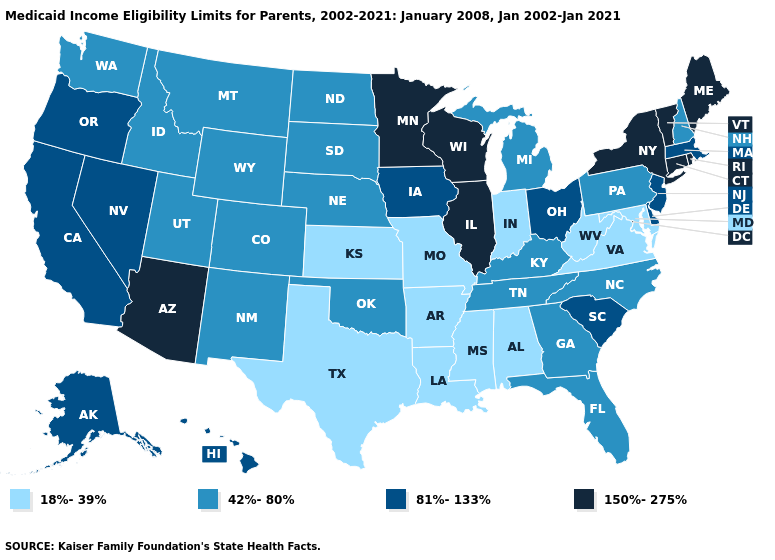Does the first symbol in the legend represent the smallest category?
Keep it brief. Yes. Among the states that border Minnesota , does Wisconsin have the highest value?
Write a very short answer. Yes. Name the states that have a value in the range 150%-275%?
Quick response, please. Arizona, Connecticut, Illinois, Maine, Minnesota, New York, Rhode Island, Vermont, Wisconsin. Is the legend a continuous bar?
Concise answer only. No. Name the states that have a value in the range 18%-39%?
Be succinct. Alabama, Arkansas, Indiana, Kansas, Louisiana, Maryland, Mississippi, Missouri, Texas, Virginia, West Virginia. What is the lowest value in the Northeast?
Keep it brief. 42%-80%. Name the states that have a value in the range 150%-275%?
Answer briefly. Arizona, Connecticut, Illinois, Maine, Minnesota, New York, Rhode Island, Vermont, Wisconsin. Name the states that have a value in the range 81%-133%?
Give a very brief answer. Alaska, California, Delaware, Hawaii, Iowa, Massachusetts, Nevada, New Jersey, Ohio, Oregon, South Carolina. What is the lowest value in the Northeast?
Answer briefly. 42%-80%. Which states hav the highest value in the Northeast?
Quick response, please. Connecticut, Maine, New York, Rhode Island, Vermont. Does Hawaii have the lowest value in the West?
Short answer required. No. Does Kentucky have the same value as Nevada?
Quick response, please. No. What is the value of Tennessee?
Keep it brief. 42%-80%. What is the highest value in the Northeast ?
Concise answer only. 150%-275%. 